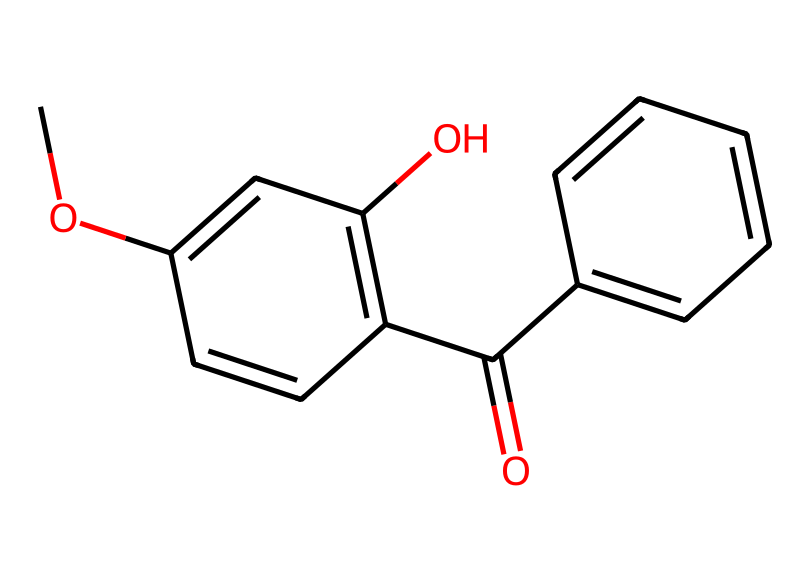What is the IUPAC name of this chemical? The chemical structure represents benzophenone-3, which is also known as oxybenzone. This information can be inferred from the arrangement of atoms and the functional groups, particularly the presence of the carbonyl group (C=O) and the benzene rings.
Answer: oxybenzone How many rings are present in the structure? Analyzing the chemical structure reveals there are two distinct cyclic structures present in the molecule, which are the two benzene rings.
Answer: 2 What type of functional group is contained in this chemical? The structure clearly shows a carbonyl group (C=O), which is a defining characteristic of ketones. Additionally, there is also a methoxy group (O-CH3) present, making it an ether as well.
Answer: carbonyl How many carbon atoms are present in this molecule? By counting the carbon atoms in the skeletal structure, which includes those in the rings and the functional groups, we find a total of 15 carbon atoms.
Answer: 15 Does this chemical have any hydroxyl (-OH) groups? Upon inspecting the structure, there is a hydroxyl group (-OH) attached to one of the benzene rings, making it evident that this compound possesses alcoholic properties.
Answer: yes What is the potential use of this chemical in cosmetics? The primary role of benzophenone-3 in cosmetics is to serve as a UV filter, protecting skin from harmful UV radiation by absorbing it. This functional purpose is derived from its specific molecular arrangement that enables UV absorption.
Answer: UV filter 